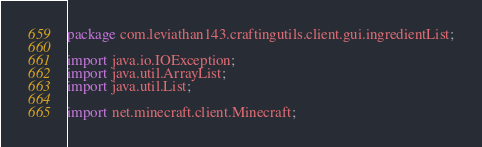Convert code to text. <code><loc_0><loc_0><loc_500><loc_500><_Java_>package com.leviathan143.craftingutils.client.gui.ingredientList;

import java.io.IOException;
import java.util.ArrayList;
import java.util.List;

import net.minecraft.client.Minecraft;</code> 